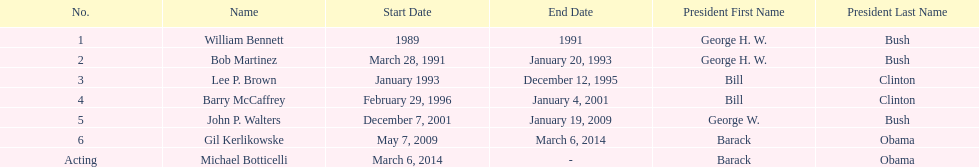What were the number of directors that stayed in office more than three years? 3. 